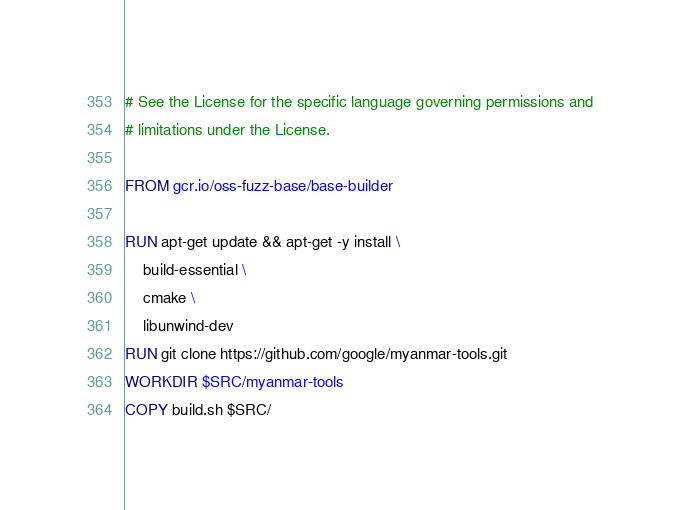<code> <loc_0><loc_0><loc_500><loc_500><_Dockerfile_># See the License for the specific language governing permissions and
# limitations under the License.

FROM gcr.io/oss-fuzz-base/base-builder

RUN apt-get update && apt-get -y install \
    build-essential \
    cmake \
    libunwind-dev
RUN git clone https://github.com/google/myanmar-tools.git
WORKDIR $SRC/myanmar-tools
COPY build.sh $SRC/
</code> 